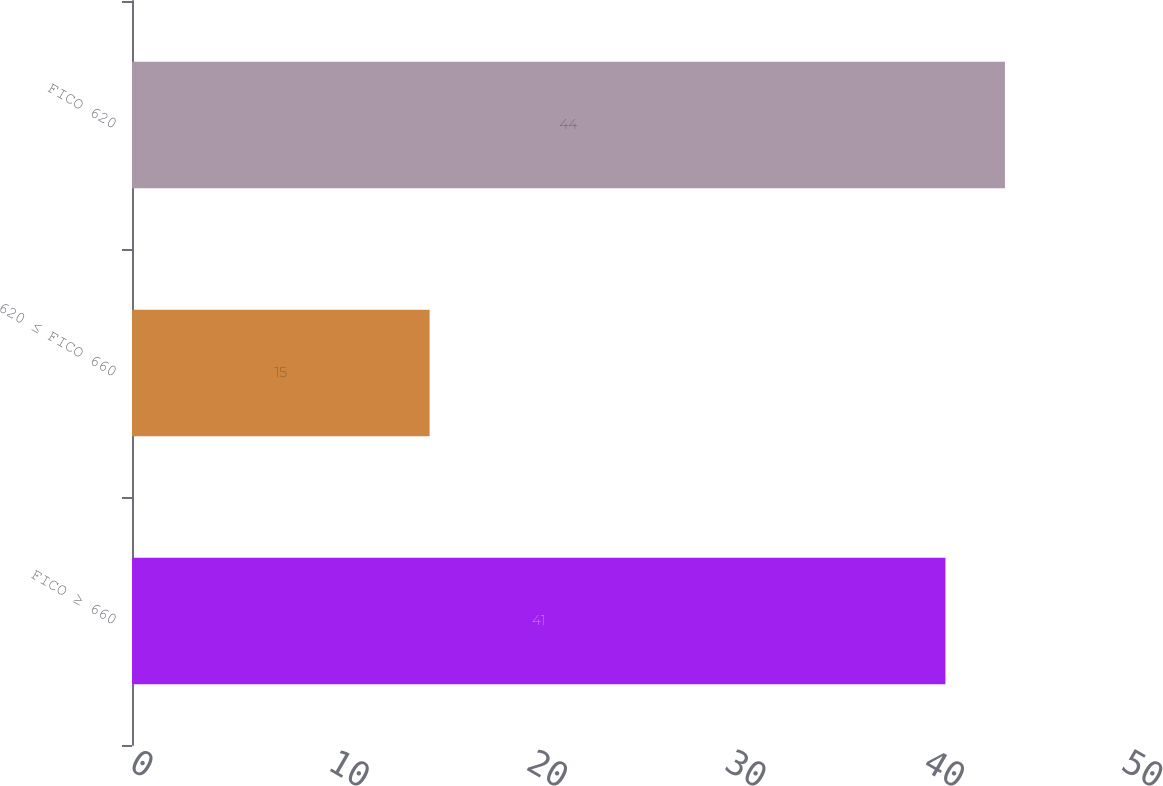<chart> <loc_0><loc_0><loc_500><loc_500><bar_chart><fcel>FICO ≥ 660<fcel>620 ≤ FICO 660<fcel>FICO 620<nl><fcel>41<fcel>15<fcel>44<nl></chart> 